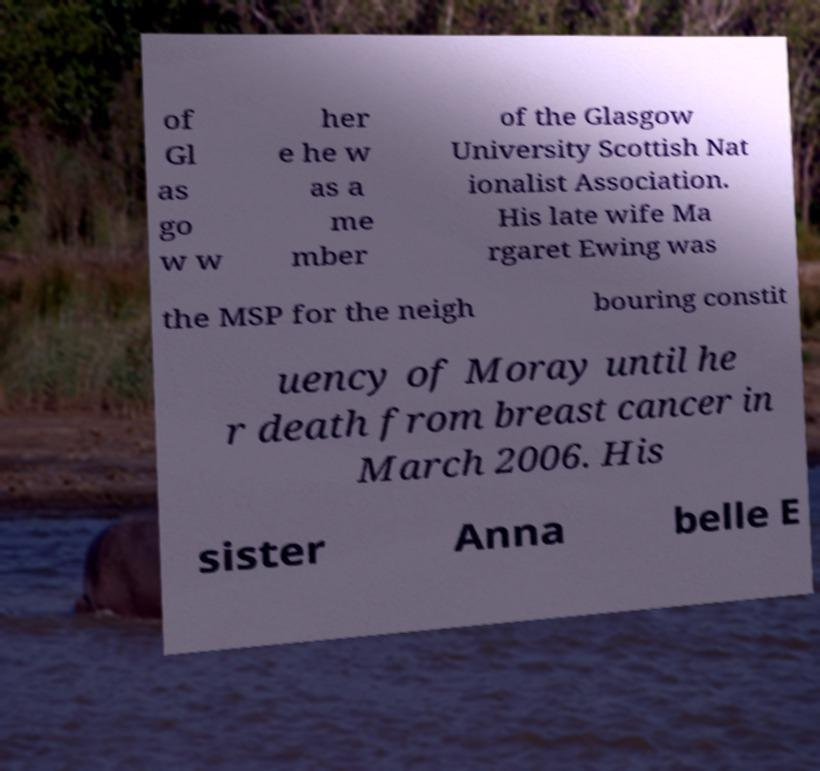Can you read and provide the text displayed in the image?This photo seems to have some interesting text. Can you extract and type it out for me? of Gl as go w w her e he w as a me mber of the Glasgow University Scottish Nat ionalist Association. His late wife Ma rgaret Ewing was the MSP for the neigh bouring constit uency of Moray until he r death from breast cancer in March 2006. His sister Anna belle E 